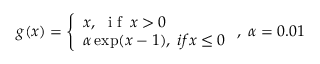<formula> <loc_0><loc_0><loc_500><loc_500>g ( x ) = \left \{ \begin{array} { l l } { x , \, i f \, x > 0 } \\ { \alpha \exp ( x - 1 ) , \, i f x \leq 0 } \end{array} , \, \alpha = 0 . 0 1</formula> 